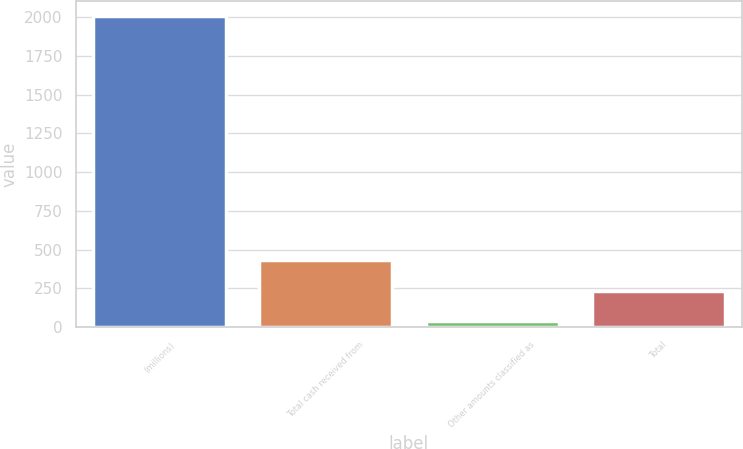<chart> <loc_0><loc_0><loc_500><loc_500><bar_chart><fcel>(millions)<fcel>Total cash received from<fcel>Other amounts classified as<fcel>Total<nl><fcel>2004<fcel>431.68<fcel>38.6<fcel>235.14<nl></chart> 